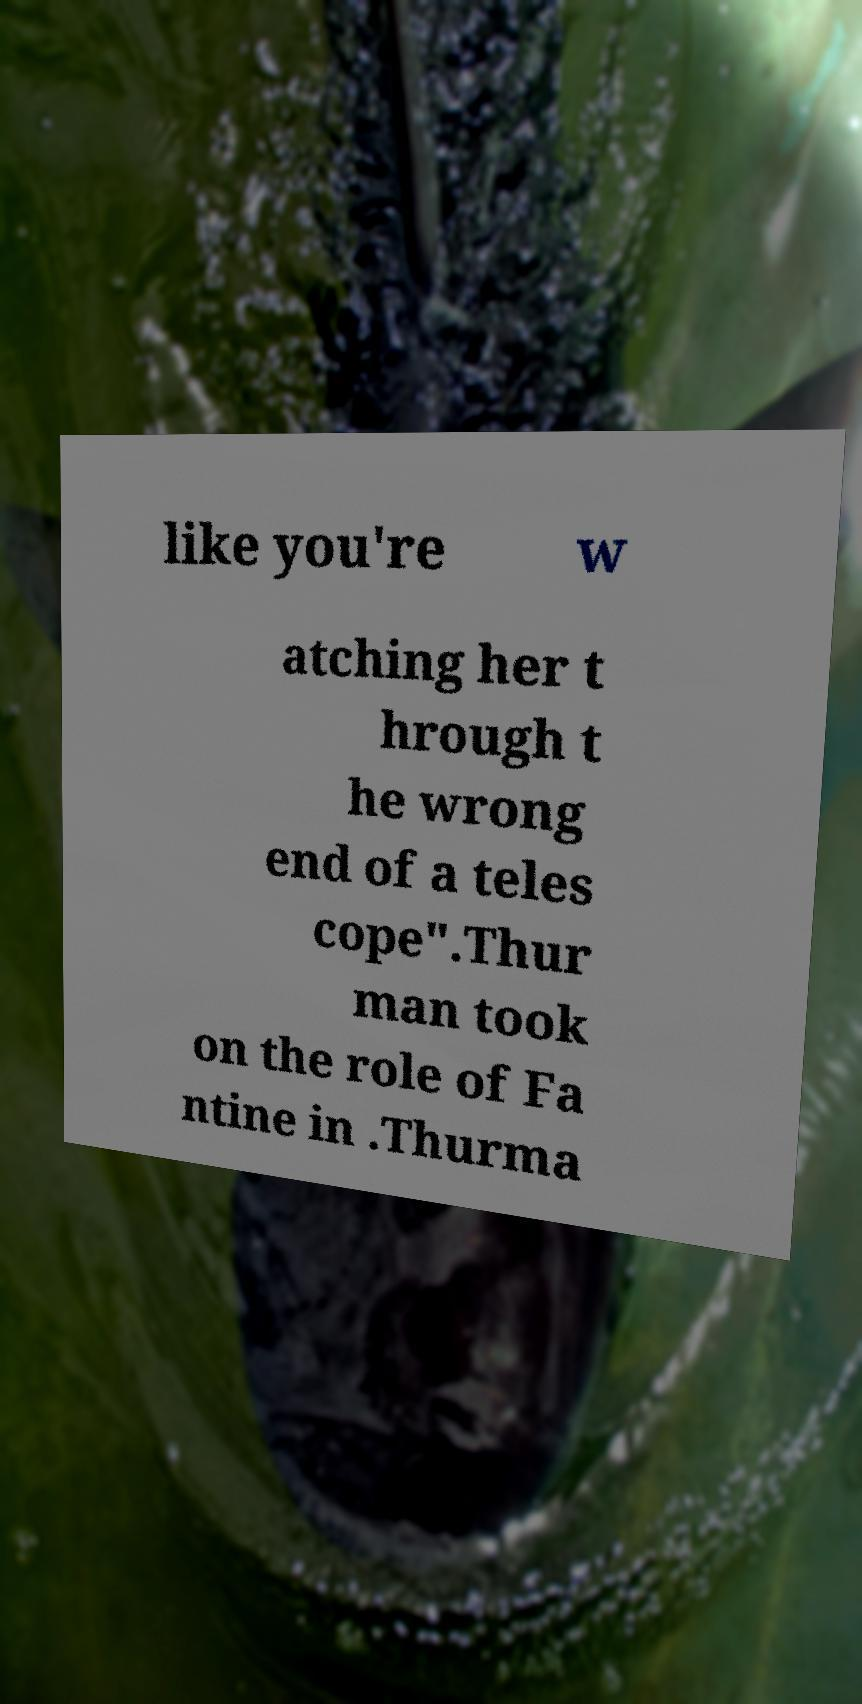Please identify and transcribe the text found in this image. like you're w atching her t hrough t he wrong end of a teles cope".Thur man took on the role of Fa ntine in .Thurma 